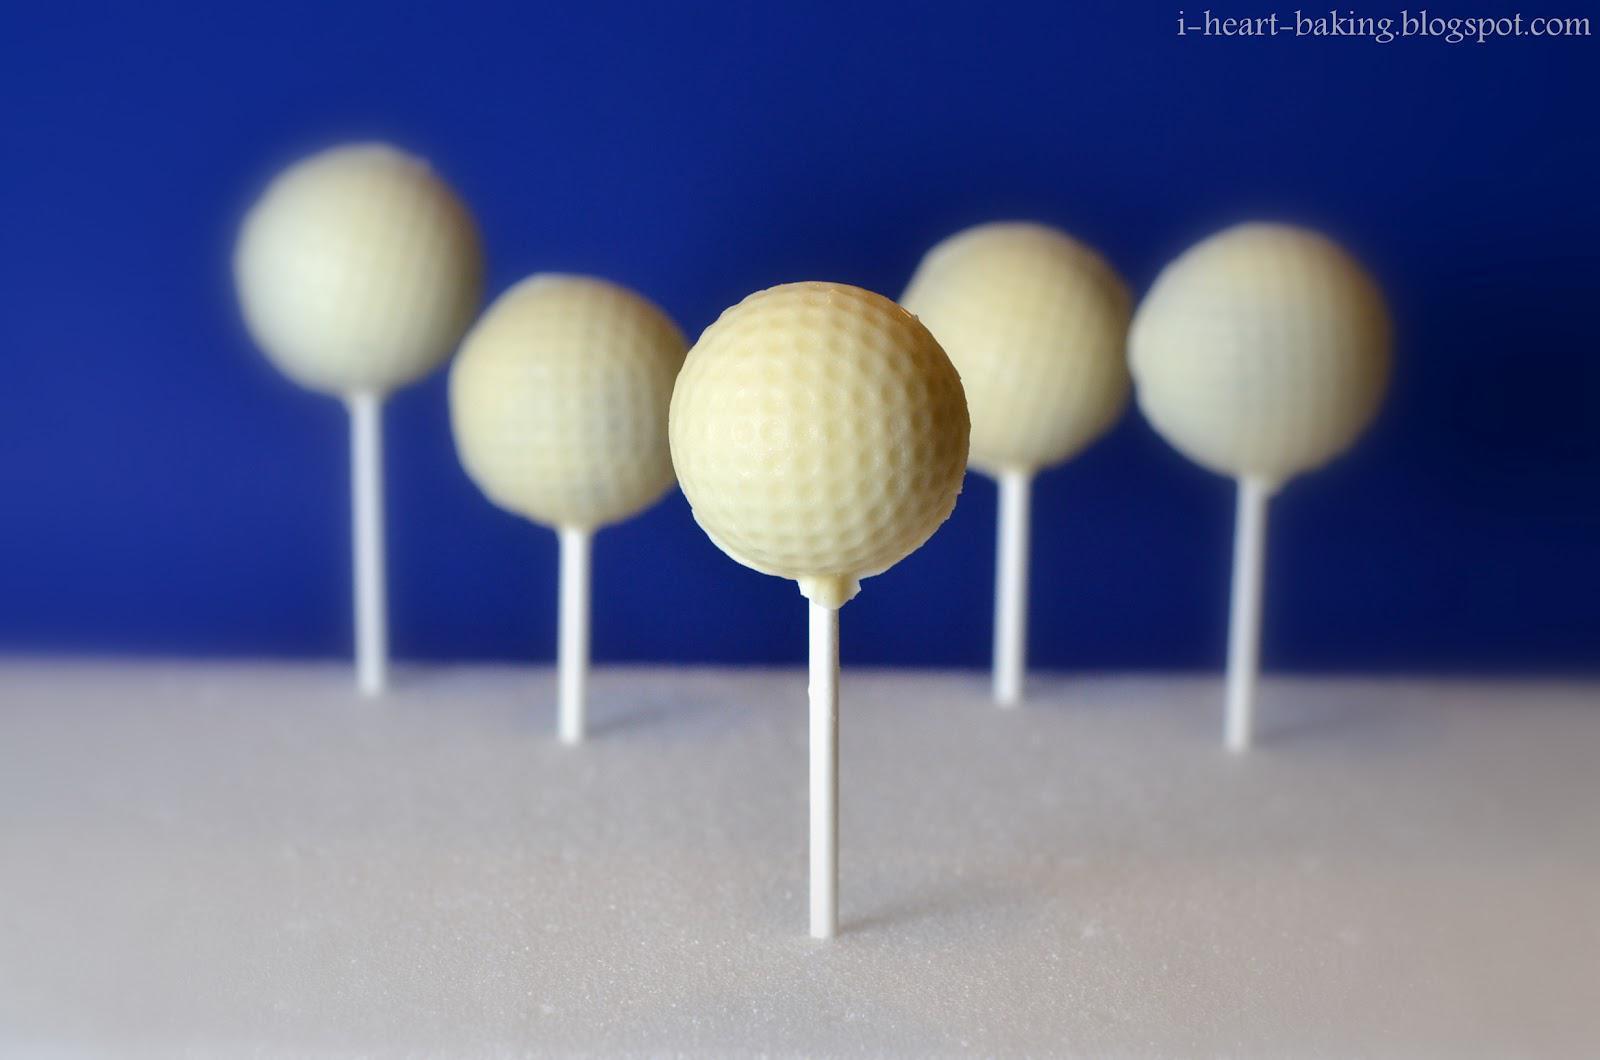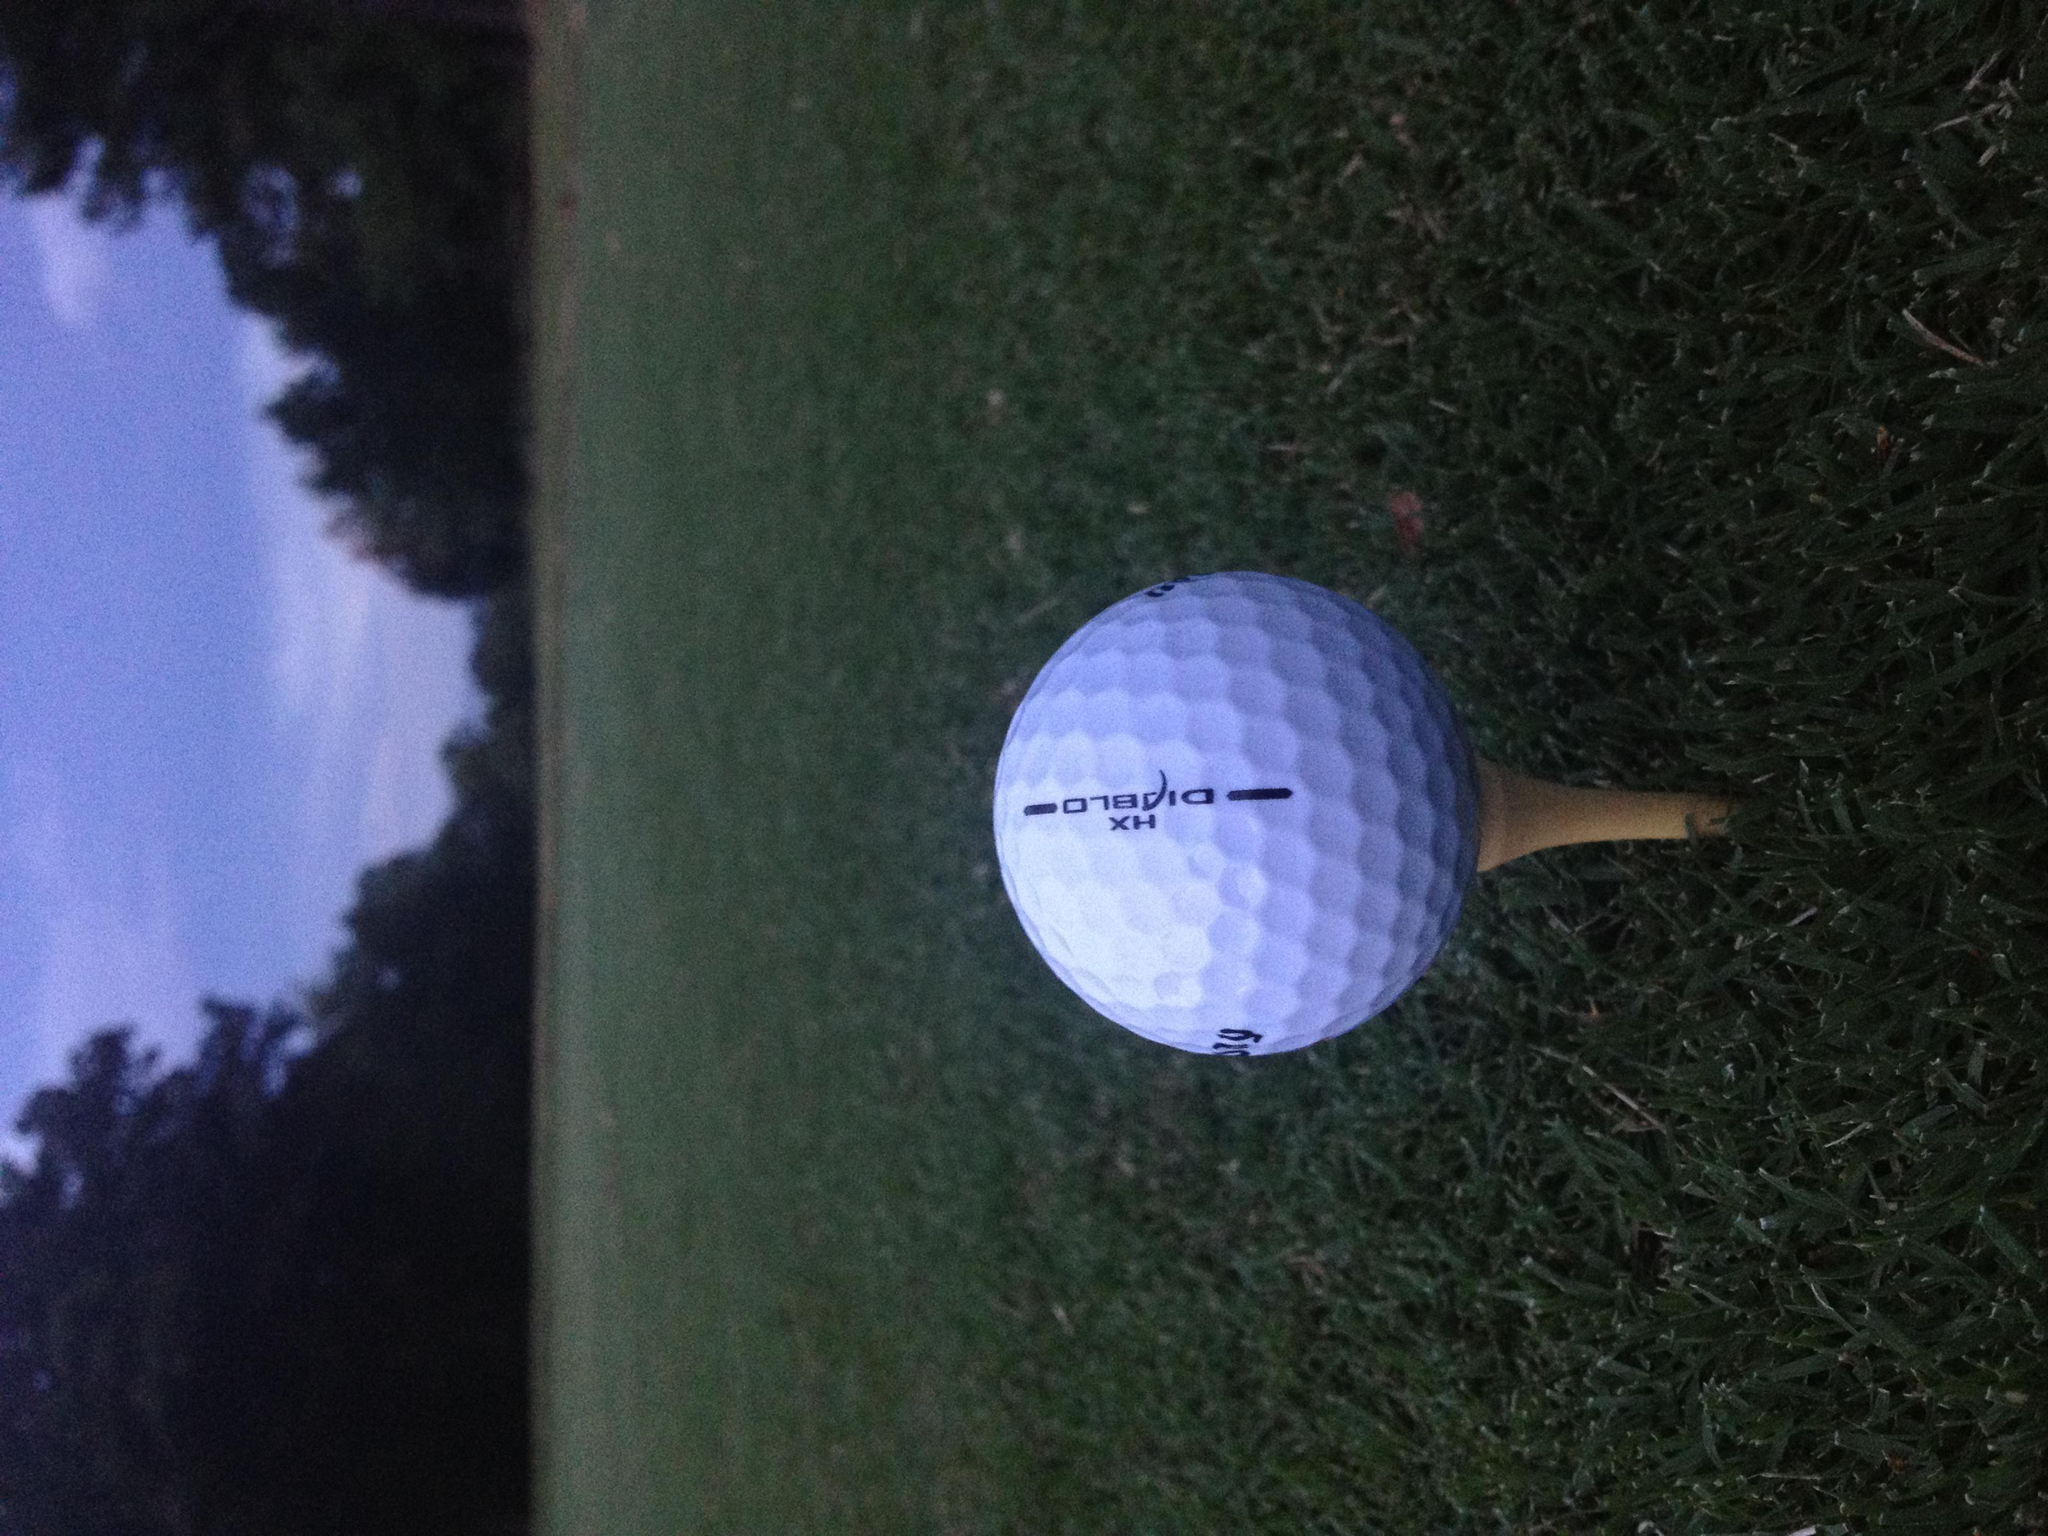The first image is the image on the left, the second image is the image on the right. Considering the images on both sides, is "There are six white golf balls and at least some of them have T holders under or near them." valid? Answer yes or no. Yes. The first image is the image on the left, the second image is the image on the right. For the images displayed, is the sentence "there are golf balls in sets of 3" factually correct? Answer yes or no. No. 